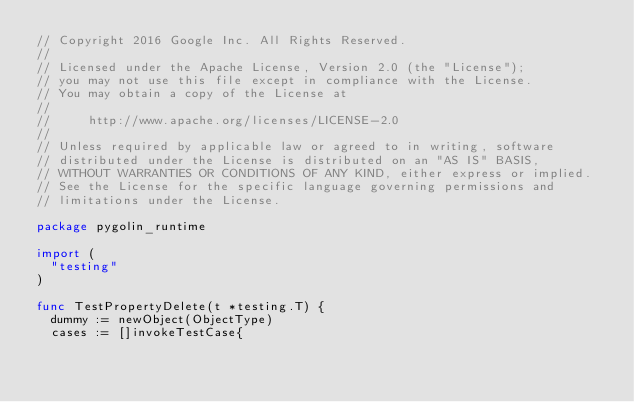<code> <loc_0><loc_0><loc_500><loc_500><_Go_>// Copyright 2016 Google Inc. All Rights Reserved.
//
// Licensed under the Apache License, Version 2.0 (the "License");
// you may not use this file except in compliance with the License.
// You may obtain a copy of the License at
//
//     http://www.apache.org/licenses/LICENSE-2.0
//
// Unless required by applicable law or agreed to in writing, software
// distributed under the License is distributed on an "AS IS" BASIS,
// WITHOUT WARRANTIES OR CONDITIONS OF ANY KIND, either express or implied.
// See the License for the specific language governing permissions and
// limitations under the License.

package pygolin_runtime

import (
	"testing"
)

func TestPropertyDelete(t *testing.T) {
	dummy := newObject(ObjectType)
	cases := []invokeTestCase{</code> 